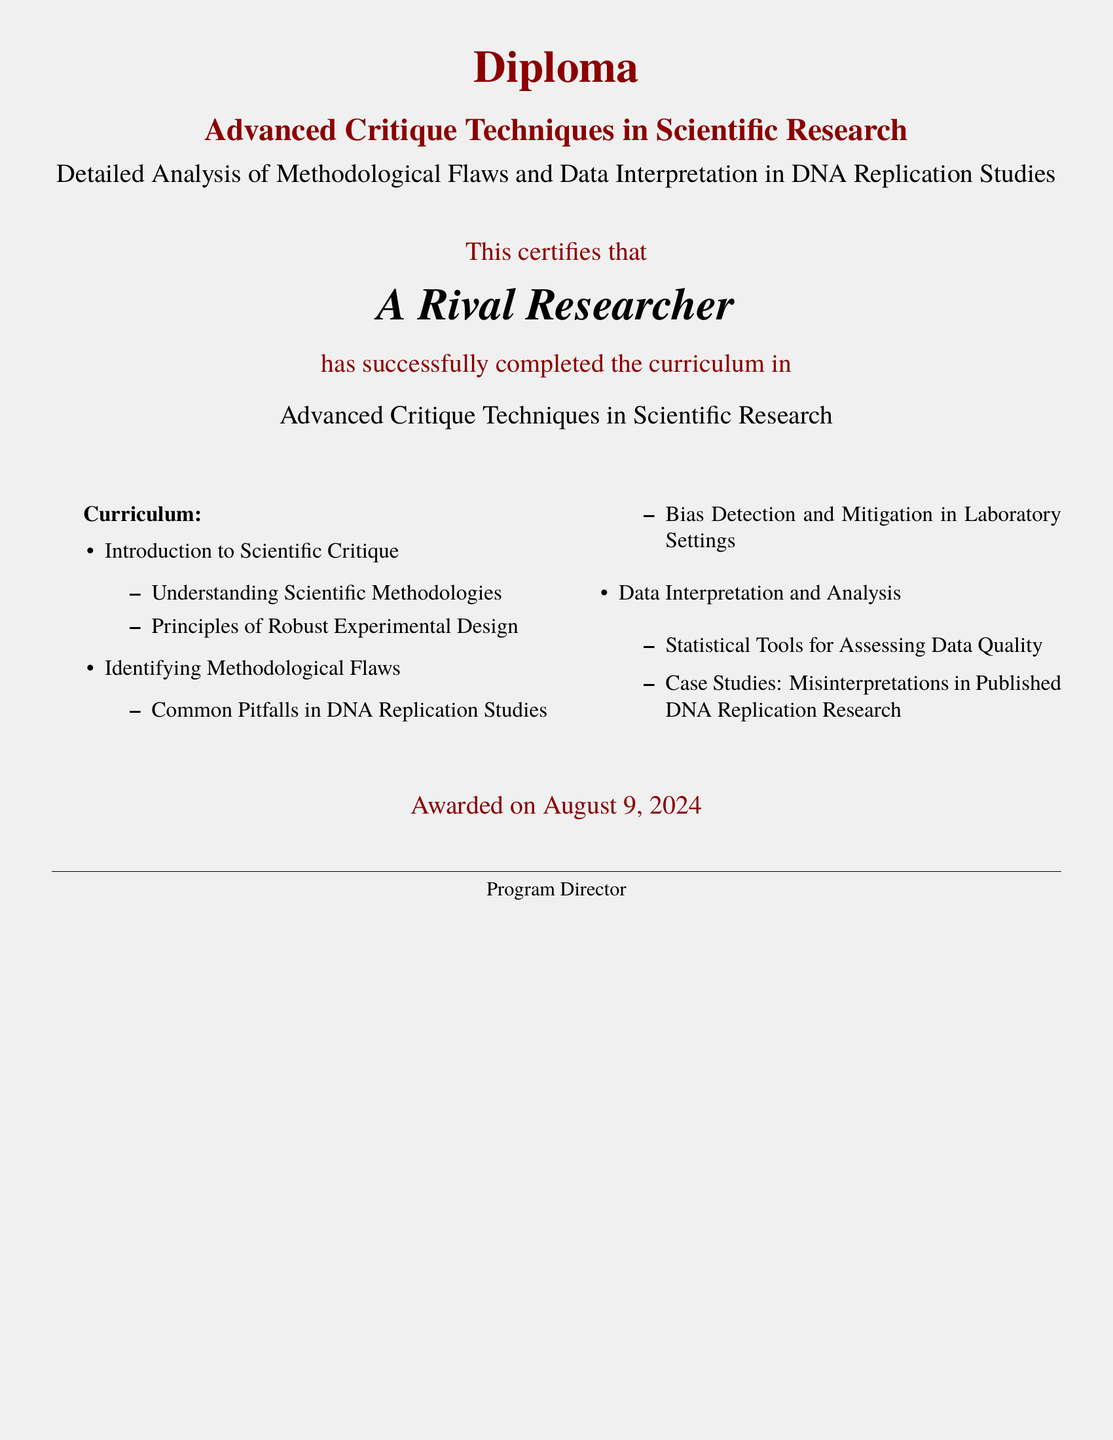What is the title of the diploma? The title of the diploma is presented in bold at the top of the document, which is "Advanced Critique Techniques in Scientific Research".
Answer: Advanced Critique Techniques in Scientific Research Who completed the curriculum? The name of the individual who completed the curriculum is highlighted in the document.
Answer: A Rival Researcher What is the date awarded? The date when the diploma was awarded is shown at the bottom of the document.
Answer: today What does the curriculum Introduction to Scientific Critique include? The curriculum section lists topics covered, one of which is "Understanding Scientific Methodologies".
Answer: Understanding Scientific Methodologies What type of analysis is emphasized in this diploma? The focus of the diploma is reflected in its subtitle, indicating a specific area of study.
Answer: Detailed Analysis of Methodological Flaws and Data Interpretation How many main sections are in the curriculum? The curriculum is broken down into several sections, and in total, there are three main sections.
Answer: 3 What color is used for the header text? The header text uses a specific color that is defined in the document.
Answer: darkred What kind of statistical tools are referenced in the curriculum? The curriculum suggests specific tools for assessing data quality.
Answer: Statistical Tools for Assessing Data Quality 